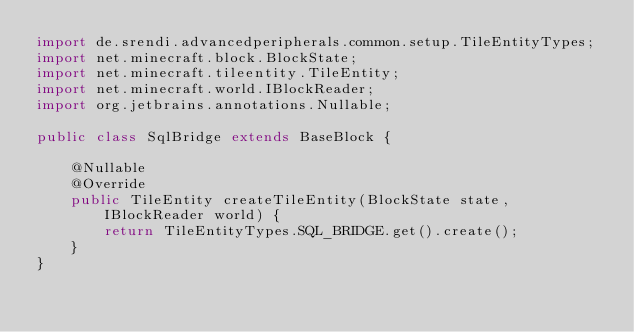Convert code to text. <code><loc_0><loc_0><loc_500><loc_500><_Java_>import de.srendi.advancedperipherals.common.setup.TileEntityTypes;
import net.minecraft.block.BlockState;
import net.minecraft.tileentity.TileEntity;
import net.minecraft.world.IBlockReader;
import org.jetbrains.annotations.Nullable;

public class SqlBridge extends BaseBlock {

    @Nullable
    @Override
    public TileEntity createTileEntity(BlockState state, IBlockReader world) {
        return TileEntityTypes.SQL_BRIDGE.get().create();
    }
}</code> 